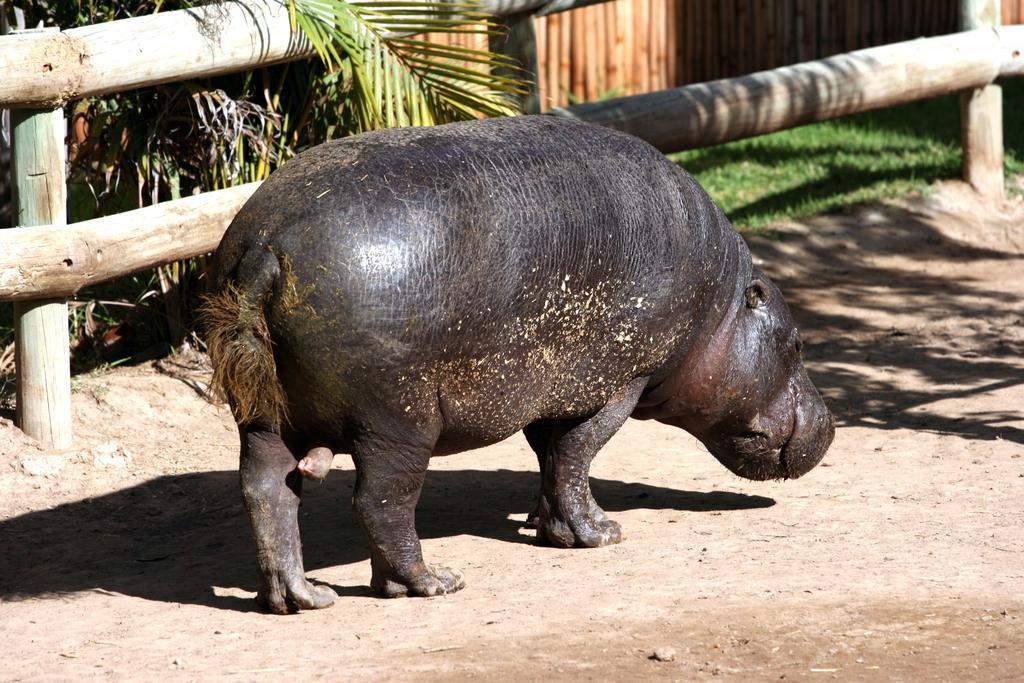Could you give a brief overview of what you see in this image? In this image, we can see a hippopotamus on the ground. Top of the image, we can see wooden fences, plants and grass. 